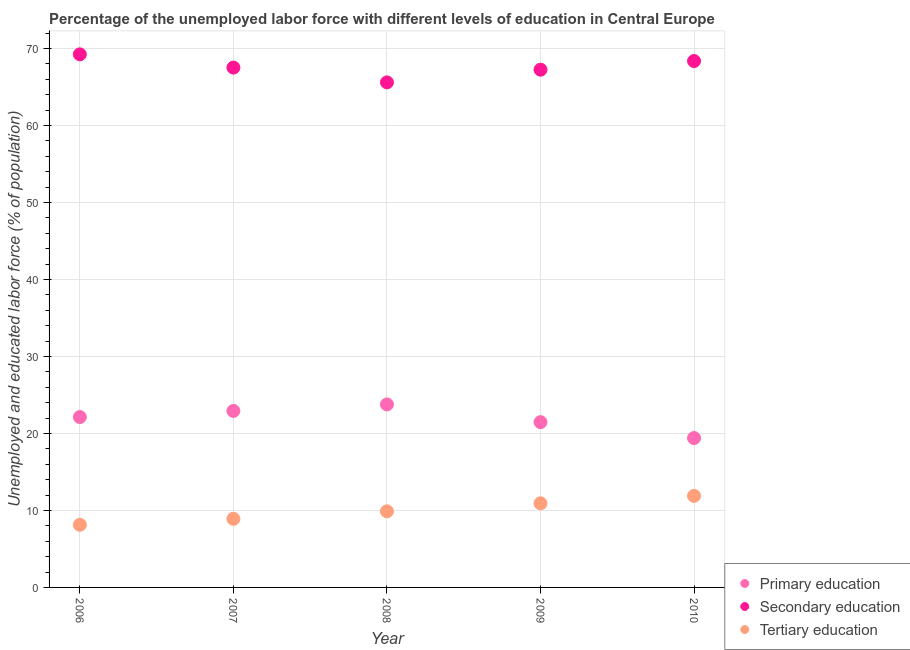What is the percentage of labor force who received primary education in 2006?
Make the answer very short. 22.13. Across all years, what is the maximum percentage of labor force who received secondary education?
Offer a terse response. 69.24. Across all years, what is the minimum percentage of labor force who received tertiary education?
Your answer should be very brief. 8.14. In which year was the percentage of labor force who received tertiary education maximum?
Your answer should be compact. 2010. In which year was the percentage of labor force who received secondary education minimum?
Provide a succinct answer. 2008. What is the total percentage of labor force who received tertiary education in the graph?
Make the answer very short. 49.76. What is the difference between the percentage of labor force who received primary education in 2007 and that in 2008?
Your response must be concise. -0.85. What is the difference between the percentage of labor force who received secondary education in 2007 and the percentage of labor force who received primary education in 2009?
Make the answer very short. 46.05. What is the average percentage of labor force who received secondary education per year?
Give a very brief answer. 67.6. In the year 2010, what is the difference between the percentage of labor force who received primary education and percentage of labor force who received tertiary education?
Keep it short and to the point. 7.51. What is the ratio of the percentage of labor force who received secondary education in 2007 to that in 2008?
Your response must be concise. 1.03. Is the percentage of labor force who received secondary education in 2006 less than that in 2010?
Ensure brevity in your answer.  No. Is the difference between the percentage of labor force who received primary education in 2006 and 2008 greater than the difference between the percentage of labor force who received tertiary education in 2006 and 2008?
Your answer should be compact. Yes. What is the difference between the highest and the second highest percentage of labor force who received primary education?
Your answer should be very brief. 0.85. What is the difference between the highest and the lowest percentage of labor force who received primary education?
Your response must be concise. 4.37. In how many years, is the percentage of labor force who received primary education greater than the average percentage of labor force who received primary education taken over all years?
Your response must be concise. 3. Is it the case that in every year, the sum of the percentage of labor force who received primary education and percentage of labor force who received secondary education is greater than the percentage of labor force who received tertiary education?
Provide a short and direct response. Yes. How many years are there in the graph?
Offer a very short reply. 5. What is the difference between two consecutive major ticks on the Y-axis?
Provide a short and direct response. 10. Does the graph contain any zero values?
Give a very brief answer. No. Does the graph contain grids?
Give a very brief answer. Yes. Where does the legend appear in the graph?
Your response must be concise. Bottom right. How are the legend labels stacked?
Your answer should be compact. Vertical. What is the title of the graph?
Your response must be concise. Percentage of the unemployed labor force with different levels of education in Central Europe. What is the label or title of the Y-axis?
Provide a succinct answer. Unemployed and educated labor force (% of population). What is the Unemployed and educated labor force (% of population) in Primary education in 2006?
Provide a short and direct response. 22.13. What is the Unemployed and educated labor force (% of population) of Secondary education in 2006?
Make the answer very short. 69.24. What is the Unemployed and educated labor force (% of population) in Tertiary education in 2006?
Your response must be concise. 8.14. What is the Unemployed and educated labor force (% of population) in Primary education in 2007?
Your answer should be compact. 22.93. What is the Unemployed and educated labor force (% of population) in Secondary education in 2007?
Your answer should be very brief. 67.52. What is the Unemployed and educated labor force (% of population) of Tertiary education in 2007?
Your response must be concise. 8.91. What is the Unemployed and educated labor force (% of population) of Primary education in 2008?
Your answer should be compact. 23.77. What is the Unemployed and educated labor force (% of population) in Secondary education in 2008?
Ensure brevity in your answer.  65.6. What is the Unemployed and educated labor force (% of population) in Tertiary education in 2008?
Provide a succinct answer. 9.89. What is the Unemployed and educated labor force (% of population) of Primary education in 2009?
Ensure brevity in your answer.  21.47. What is the Unemployed and educated labor force (% of population) in Secondary education in 2009?
Give a very brief answer. 67.25. What is the Unemployed and educated labor force (% of population) in Tertiary education in 2009?
Ensure brevity in your answer.  10.93. What is the Unemployed and educated labor force (% of population) in Primary education in 2010?
Give a very brief answer. 19.41. What is the Unemployed and educated labor force (% of population) in Secondary education in 2010?
Your answer should be compact. 68.38. What is the Unemployed and educated labor force (% of population) of Tertiary education in 2010?
Keep it short and to the point. 11.89. Across all years, what is the maximum Unemployed and educated labor force (% of population) in Primary education?
Offer a terse response. 23.77. Across all years, what is the maximum Unemployed and educated labor force (% of population) of Secondary education?
Make the answer very short. 69.24. Across all years, what is the maximum Unemployed and educated labor force (% of population) of Tertiary education?
Give a very brief answer. 11.89. Across all years, what is the minimum Unemployed and educated labor force (% of population) in Primary education?
Offer a very short reply. 19.41. Across all years, what is the minimum Unemployed and educated labor force (% of population) in Secondary education?
Ensure brevity in your answer.  65.6. Across all years, what is the minimum Unemployed and educated labor force (% of population) of Tertiary education?
Make the answer very short. 8.14. What is the total Unemployed and educated labor force (% of population) of Primary education in the graph?
Give a very brief answer. 109.71. What is the total Unemployed and educated labor force (% of population) of Secondary education in the graph?
Your response must be concise. 338. What is the total Unemployed and educated labor force (% of population) of Tertiary education in the graph?
Provide a short and direct response. 49.76. What is the difference between the Unemployed and educated labor force (% of population) of Primary education in 2006 and that in 2007?
Make the answer very short. -0.79. What is the difference between the Unemployed and educated labor force (% of population) of Secondary education in 2006 and that in 2007?
Offer a terse response. 1.72. What is the difference between the Unemployed and educated labor force (% of population) in Tertiary education in 2006 and that in 2007?
Provide a short and direct response. -0.78. What is the difference between the Unemployed and educated labor force (% of population) in Primary education in 2006 and that in 2008?
Provide a succinct answer. -1.64. What is the difference between the Unemployed and educated labor force (% of population) of Secondary education in 2006 and that in 2008?
Ensure brevity in your answer.  3.64. What is the difference between the Unemployed and educated labor force (% of population) of Tertiary education in 2006 and that in 2008?
Give a very brief answer. -1.75. What is the difference between the Unemployed and educated labor force (% of population) of Primary education in 2006 and that in 2009?
Offer a terse response. 0.66. What is the difference between the Unemployed and educated labor force (% of population) in Secondary education in 2006 and that in 2009?
Your answer should be compact. 1.99. What is the difference between the Unemployed and educated labor force (% of population) of Tertiary education in 2006 and that in 2009?
Make the answer very short. -2.79. What is the difference between the Unemployed and educated labor force (% of population) of Primary education in 2006 and that in 2010?
Ensure brevity in your answer.  2.73. What is the difference between the Unemployed and educated labor force (% of population) of Secondary education in 2006 and that in 2010?
Give a very brief answer. 0.87. What is the difference between the Unemployed and educated labor force (% of population) of Tertiary education in 2006 and that in 2010?
Ensure brevity in your answer.  -3.76. What is the difference between the Unemployed and educated labor force (% of population) in Primary education in 2007 and that in 2008?
Your response must be concise. -0.85. What is the difference between the Unemployed and educated labor force (% of population) in Secondary education in 2007 and that in 2008?
Offer a terse response. 1.92. What is the difference between the Unemployed and educated labor force (% of population) of Tertiary education in 2007 and that in 2008?
Ensure brevity in your answer.  -0.97. What is the difference between the Unemployed and educated labor force (% of population) of Primary education in 2007 and that in 2009?
Offer a terse response. 1.45. What is the difference between the Unemployed and educated labor force (% of population) in Secondary education in 2007 and that in 2009?
Your response must be concise. 0.27. What is the difference between the Unemployed and educated labor force (% of population) in Tertiary education in 2007 and that in 2009?
Ensure brevity in your answer.  -2.02. What is the difference between the Unemployed and educated labor force (% of population) of Primary education in 2007 and that in 2010?
Give a very brief answer. 3.52. What is the difference between the Unemployed and educated labor force (% of population) of Secondary education in 2007 and that in 2010?
Your answer should be compact. -0.85. What is the difference between the Unemployed and educated labor force (% of population) in Tertiary education in 2007 and that in 2010?
Your answer should be very brief. -2.98. What is the difference between the Unemployed and educated labor force (% of population) in Primary education in 2008 and that in 2009?
Your answer should be very brief. 2.3. What is the difference between the Unemployed and educated labor force (% of population) in Secondary education in 2008 and that in 2009?
Provide a succinct answer. -1.65. What is the difference between the Unemployed and educated labor force (% of population) in Tertiary education in 2008 and that in 2009?
Your answer should be compact. -1.04. What is the difference between the Unemployed and educated labor force (% of population) of Primary education in 2008 and that in 2010?
Ensure brevity in your answer.  4.37. What is the difference between the Unemployed and educated labor force (% of population) of Secondary education in 2008 and that in 2010?
Give a very brief answer. -2.78. What is the difference between the Unemployed and educated labor force (% of population) in Tertiary education in 2008 and that in 2010?
Your answer should be compact. -2.01. What is the difference between the Unemployed and educated labor force (% of population) of Primary education in 2009 and that in 2010?
Give a very brief answer. 2.07. What is the difference between the Unemployed and educated labor force (% of population) in Secondary education in 2009 and that in 2010?
Your answer should be compact. -1.13. What is the difference between the Unemployed and educated labor force (% of population) in Tertiary education in 2009 and that in 2010?
Provide a short and direct response. -0.97. What is the difference between the Unemployed and educated labor force (% of population) in Primary education in 2006 and the Unemployed and educated labor force (% of population) in Secondary education in 2007?
Provide a succinct answer. -45.39. What is the difference between the Unemployed and educated labor force (% of population) in Primary education in 2006 and the Unemployed and educated labor force (% of population) in Tertiary education in 2007?
Give a very brief answer. 13.22. What is the difference between the Unemployed and educated labor force (% of population) of Secondary education in 2006 and the Unemployed and educated labor force (% of population) of Tertiary education in 2007?
Offer a very short reply. 60.33. What is the difference between the Unemployed and educated labor force (% of population) of Primary education in 2006 and the Unemployed and educated labor force (% of population) of Secondary education in 2008?
Offer a very short reply. -43.47. What is the difference between the Unemployed and educated labor force (% of population) of Primary education in 2006 and the Unemployed and educated labor force (% of population) of Tertiary education in 2008?
Your answer should be very brief. 12.25. What is the difference between the Unemployed and educated labor force (% of population) of Secondary education in 2006 and the Unemployed and educated labor force (% of population) of Tertiary education in 2008?
Make the answer very short. 59.36. What is the difference between the Unemployed and educated labor force (% of population) in Primary education in 2006 and the Unemployed and educated labor force (% of population) in Secondary education in 2009?
Your answer should be compact. -45.12. What is the difference between the Unemployed and educated labor force (% of population) of Primary education in 2006 and the Unemployed and educated labor force (% of population) of Tertiary education in 2009?
Offer a terse response. 11.2. What is the difference between the Unemployed and educated labor force (% of population) in Secondary education in 2006 and the Unemployed and educated labor force (% of population) in Tertiary education in 2009?
Ensure brevity in your answer.  58.32. What is the difference between the Unemployed and educated labor force (% of population) of Primary education in 2006 and the Unemployed and educated labor force (% of population) of Secondary education in 2010?
Ensure brevity in your answer.  -46.24. What is the difference between the Unemployed and educated labor force (% of population) in Primary education in 2006 and the Unemployed and educated labor force (% of population) in Tertiary education in 2010?
Offer a very short reply. 10.24. What is the difference between the Unemployed and educated labor force (% of population) in Secondary education in 2006 and the Unemployed and educated labor force (% of population) in Tertiary education in 2010?
Provide a succinct answer. 57.35. What is the difference between the Unemployed and educated labor force (% of population) of Primary education in 2007 and the Unemployed and educated labor force (% of population) of Secondary education in 2008?
Make the answer very short. -42.68. What is the difference between the Unemployed and educated labor force (% of population) in Primary education in 2007 and the Unemployed and educated labor force (% of population) in Tertiary education in 2008?
Your answer should be very brief. 13.04. What is the difference between the Unemployed and educated labor force (% of population) in Secondary education in 2007 and the Unemployed and educated labor force (% of population) in Tertiary education in 2008?
Keep it short and to the point. 57.64. What is the difference between the Unemployed and educated labor force (% of population) in Primary education in 2007 and the Unemployed and educated labor force (% of population) in Secondary education in 2009?
Ensure brevity in your answer.  -44.33. What is the difference between the Unemployed and educated labor force (% of population) of Primary education in 2007 and the Unemployed and educated labor force (% of population) of Tertiary education in 2009?
Offer a very short reply. 12. What is the difference between the Unemployed and educated labor force (% of population) in Secondary education in 2007 and the Unemployed and educated labor force (% of population) in Tertiary education in 2009?
Offer a terse response. 56.59. What is the difference between the Unemployed and educated labor force (% of population) of Primary education in 2007 and the Unemployed and educated labor force (% of population) of Secondary education in 2010?
Your response must be concise. -45.45. What is the difference between the Unemployed and educated labor force (% of population) of Primary education in 2007 and the Unemployed and educated labor force (% of population) of Tertiary education in 2010?
Offer a terse response. 11.03. What is the difference between the Unemployed and educated labor force (% of population) in Secondary education in 2007 and the Unemployed and educated labor force (% of population) in Tertiary education in 2010?
Offer a terse response. 55.63. What is the difference between the Unemployed and educated labor force (% of population) of Primary education in 2008 and the Unemployed and educated labor force (% of population) of Secondary education in 2009?
Your answer should be compact. -43.48. What is the difference between the Unemployed and educated labor force (% of population) in Primary education in 2008 and the Unemployed and educated labor force (% of population) in Tertiary education in 2009?
Make the answer very short. 12.85. What is the difference between the Unemployed and educated labor force (% of population) in Secondary education in 2008 and the Unemployed and educated labor force (% of population) in Tertiary education in 2009?
Make the answer very short. 54.67. What is the difference between the Unemployed and educated labor force (% of population) in Primary education in 2008 and the Unemployed and educated labor force (% of population) in Secondary education in 2010?
Your response must be concise. -44.6. What is the difference between the Unemployed and educated labor force (% of population) of Primary education in 2008 and the Unemployed and educated labor force (% of population) of Tertiary education in 2010?
Your answer should be very brief. 11.88. What is the difference between the Unemployed and educated labor force (% of population) of Secondary education in 2008 and the Unemployed and educated labor force (% of population) of Tertiary education in 2010?
Provide a short and direct response. 53.71. What is the difference between the Unemployed and educated labor force (% of population) in Primary education in 2009 and the Unemployed and educated labor force (% of population) in Secondary education in 2010?
Your response must be concise. -46.91. What is the difference between the Unemployed and educated labor force (% of population) of Primary education in 2009 and the Unemployed and educated labor force (% of population) of Tertiary education in 2010?
Your answer should be very brief. 9.58. What is the difference between the Unemployed and educated labor force (% of population) of Secondary education in 2009 and the Unemployed and educated labor force (% of population) of Tertiary education in 2010?
Your answer should be very brief. 55.36. What is the average Unemployed and educated labor force (% of population) in Primary education per year?
Your answer should be very brief. 21.94. What is the average Unemployed and educated labor force (% of population) in Secondary education per year?
Your answer should be compact. 67.6. What is the average Unemployed and educated labor force (% of population) of Tertiary education per year?
Offer a very short reply. 9.95. In the year 2006, what is the difference between the Unemployed and educated labor force (% of population) of Primary education and Unemployed and educated labor force (% of population) of Secondary education?
Offer a terse response. -47.11. In the year 2006, what is the difference between the Unemployed and educated labor force (% of population) of Primary education and Unemployed and educated labor force (% of population) of Tertiary education?
Offer a very short reply. 14. In the year 2006, what is the difference between the Unemployed and educated labor force (% of population) in Secondary education and Unemployed and educated labor force (% of population) in Tertiary education?
Your answer should be compact. 61.11. In the year 2007, what is the difference between the Unemployed and educated labor force (% of population) of Primary education and Unemployed and educated labor force (% of population) of Secondary education?
Keep it short and to the point. -44.6. In the year 2007, what is the difference between the Unemployed and educated labor force (% of population) of Primary education and Unemployed and educated labor force (% of population) of Tertiary education?
Give a very brief answer. 14.01. In the year 2007, what is the difference between the Unemployed and educated labor force (% of population) of Secondary education and Unemployed and educated labor force (% of population) of Tertiary education?
Your response must be concise. 58.61. In the year 2008, what is the difference between the Unemployed and educated labor force (% of population) of Primary education and Unemployed and educated labor force (% of population) of Secondary education?
Provide a succinct answer. -41.83. In the year 2008, what is the difference between the Unemployed and educated labor force (% of population) in Primary education and Unemployed and educated labor force (% of population) in Tertiary education?
Your answer should be very brief. 13.89. In the year 2008, what is the difference between the Unemployed and educated labor force (% of population) of Secondary education and Unemployed and educated labor force (% of population) of Tertiary education?
Your answer should be very brief. 55.72. In the year 2009, what is the difference between the Unemployed and educated labor force (% of population) in Primary education and Unemployed and educated labor force (% of population) in Secondary education?
Ensure brevity in your answer.  -45.78. In the year 2009, what is the difference between the Unemployed and educated labor force (% of population) in Primary education and Unemployed and educated labor force (% of population) in Tertiary education?
Give a very brief answer. 10.54. In the year 2009, what is the difference between the Unemployed and educated labor force (% of population) of Secondary education and Unemployed and educated labor force (% of population) of Tertiary education?
Provide a succinct answer. 56.32. In the year 2010, what is the difference between the Unemployed and educated labor force (% of population) of Primary education and Unemployed and educated labor force (% of population) of Secondary education?
Offer a very short reply. -48.97. In the year 2010, what is the difference between the Unemployed and educated labor force (% of population) in Primary education and Unemployed and educated labor force (% of population) in Tertiary education?
Provide a short and direct response. 7.51. In the year 2010, what is the difference between the Unemployed and educated labor force (% of population) in Secondary education and Unemployed and educated labor force (% of population) in Tertiary education?
Offer a terse response. 56.48. What is the ratio of the Unemployed and educated labor force (% of population) of Primary education in 2006 to that in 2007?
Your response must be concise. 0.97. What is the ratio of the Unemployed and educated labor force (% of population) of Secondary education in 2006 to that in 2007?
Give a very brief answer. 1.03. What is the ratio of the Unemployed and educated labor force (% of population) in Tertiary education in 2006 to that in 2007?
Provide a short and direct response. 0.91. What is the ratio of the Unemployed and educated labor force (% of population) of Secondary education in 2006 to that in 2008?
Your answer should be compact. 1.06. What is the ratio of the Unemployed and educated labor force (% of population) in Tertiary education in 2006 to that in 2008?
Provide a short and direct response. 0.82. What is the ratio of the Unemployed and educated labor force (% of population) in Primary education in 2006 to that in 2009?
Provide a short and direct response. 1.03. What is the ratio of the Unemployed and educated labor force (% of population) in Secondary education in 2006 to that in 2009?
Your answer should be very brief. 1.03. What is the ratio of the Unemployed and educated labor force (% of population) of Tertiary education in 2006 to that in 2009?
Keep it short and to the point. 0.74. What is the ratio of the Unemployed and educated labor force (% of population) of Primary education in 2006 to that in 2010?
Provide a short and direct response. 1.14. What is the ratio of the Unemployed and educated labor force (% of population) of Secondary education in 2006 to that in 2010?
Offer a very short reply. 1.01. What is the ratio of the Unemployed and educated labor force (% of population) in Tertiary education in 2006 to that in 2010?
Your answer should be compact. 0.68. What is the ratio of the Unemployed and educated labor force (% of population) of Primary education in 2007 to that in 2008?
Your response must be concise. 0.96. What is the ratio of the Unemployed and educated labor force (% of population) in Secondary education in 2007 to that in 2008?
Provide a succinct answer. 1.03. What is the ratio of the Unemployed and educated labor force (% of population) of Tertiary education in 2007 to that in 2008?
Provide a short and direct response. 0.9. What is the ratio of the Unemployed and educated labor force (% of population) in Primary education in 2007 to that in 2009?
Give a very brief answer. 1.07. What is the ratio of the Unemployed and educated labor force (% of population) of Tertiary education in 2007 to that in 2009?
Make the answer very short. 0.82. What is the ratio of the Unemployed and educated labor force (% of population) of Primary education in 2007 to that in 2010?
Make the answer very short. 1.18. What is the ratio of the Unemployed and educated labor force (% of population) of Secondary education in 2007 to that in 2010?
Keep it short and to the point. 0.99. What is the ratio of the Unemployed and educated labor force (% of population) in Tertiary education in 2007 to that in 2010?
Offer a very short reply. 0.75. What is the ratio of the Unemployed and educated labor force (% of population) in Primary education in 2008 to that in 2009?
Give a very brief answer. 1.11. What is the ratio of the Unemployed and educated labor force (% of population) of Secondary education in 2008 to that in 2009?
Make the answer very short. 0.98. What is the ratio of the Unemployed and educated labor force (% of population) in Tertiary education in 2008 to that in 2009?
Keep it short and to the point. 0.9. What is the ratio of the Unemployed and educated labor force (% of population) in Primary education in 2008 to that in 2010?
Offer a very short reply. 1.23. What is the ratio of the Unemployed and educated labor force (% of population) of Secondary education in 2008 to that in 2010?
Provide a short and direct response. 0.96. What is the ratio of the Unemployed and educated labor force (% of population) of Tertiary education in 2008 to that in 2010?
Offer a very short reply. 0.83. What is the ratio of the Unemployed and educated labor force (% of population) of Primary education in 2009 to that in 2010?
Give a very brief answer. 1.11. What is the ratio of the Unemployed and educated labor force (% of population) of Secondary education in 2009 to that in 2010?
Your response must be concise. 0.98. What is the ratio of the Unemployed and educated labor force (% of population) of Tertiary education in 2009 to that in 2010?
Make the answer very short. 0.92. What is the difference between the highest and the second highest Unemployed and educated labor force (% of population) of Primary education?
Your response must be concise. 0.85. What is the difference between the highest and the second highest Unemployed and educated labor force (% of population) in Secondary education?
Provide a succinct answer. 0.87. What is the difference between the highest and the second highest Unemployed and educated labor force (% of population) of Tertiary education?
Keep it short and to the point. 0.97. What is the difference between the highest and the lowest Unemployed and educated labor force (% of population) in Primary education?
Your answer should be compact. 4.37. What is the difference between the highest and the lowest Unemployed and educated labor force (% of population) in Secondary education?
Your response must be concise. 3.64. What is the difference between the highest and the lowest Unemployed and educated labor force (% of population) of Tertiary education?
Make the answer very short. 3.76. 